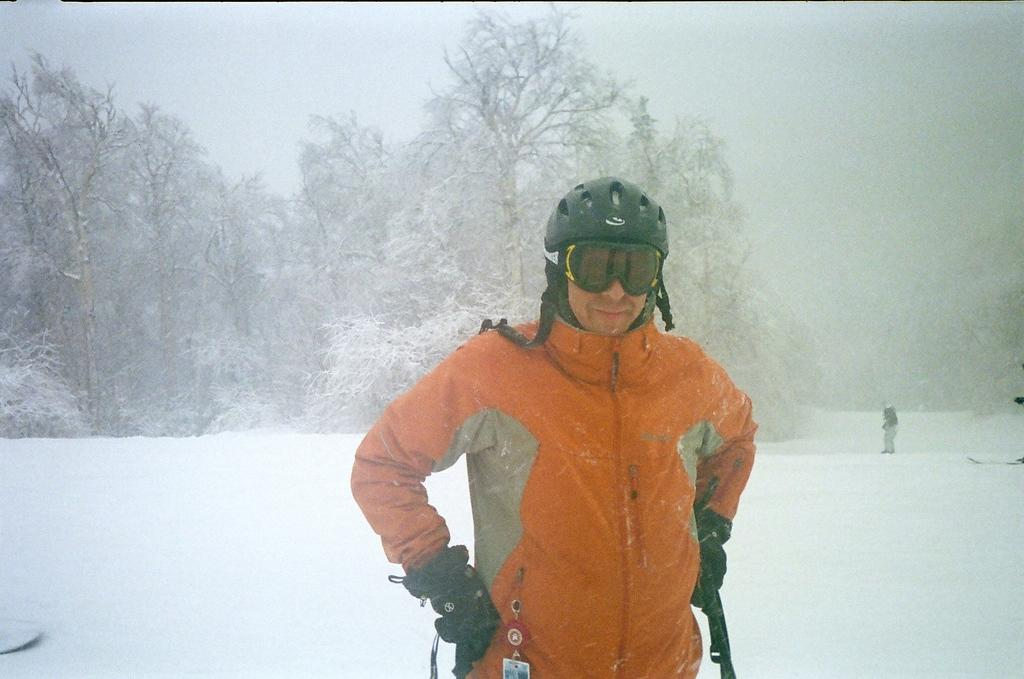What is the person in the image wearing on their head? The person is wearing a helmet. What type of clothing is the person wearing on their upper body? The person is wearing a jacket. What type of eye protection is the person wearing? The person is wearing goggles. What type of hand protection is the person wearing? The person is wearing gloves. How is the person feeling in the image? The person is smiling. What can be seen in the background of the image? There are trees and snow visible in the background, along with another person and some objects. What type of feast is being prepared in the background of the image? There is no feast visible in the image; it primarily features a person wearing protective gear in a snowy environment. 